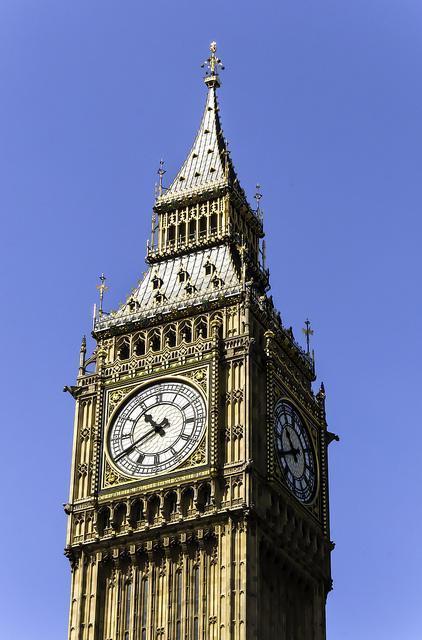How many clocks are there?
Give a very brief answer. 2. How many elephants are there?
Give a very brief answer. 0. 